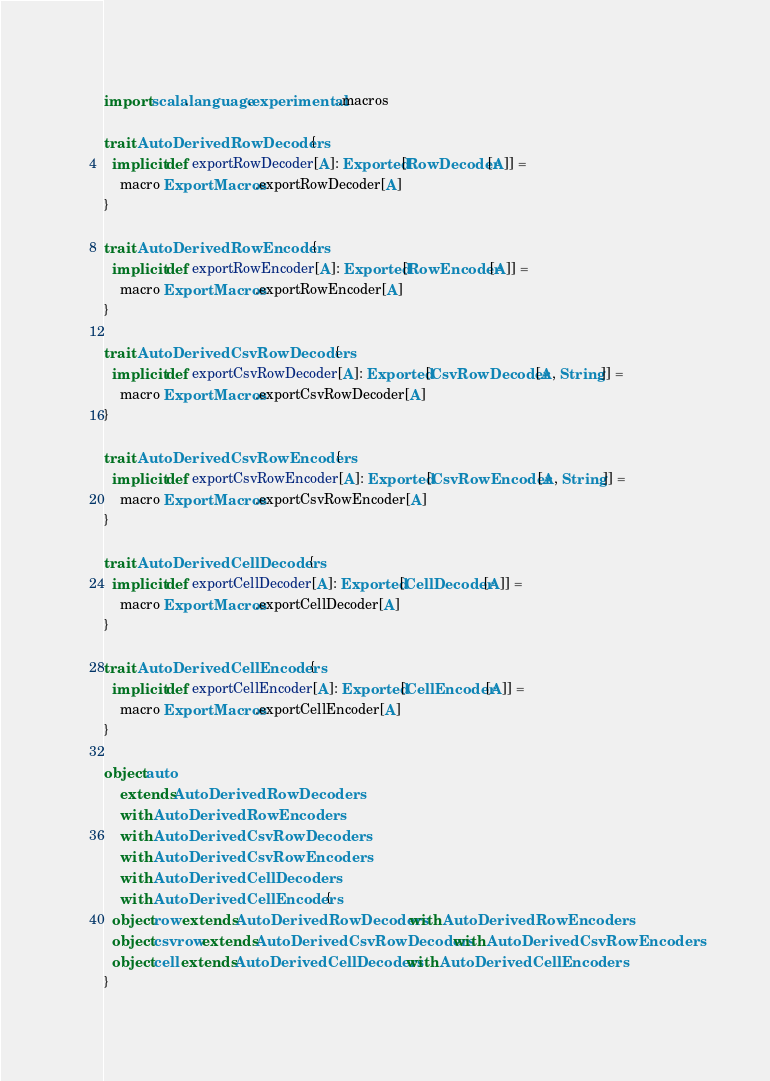<code> <loc_0><loc_0><loc_500><loc_500><_Scala_>
import scala.language.experimental.macros

trait AutoDerivedRowDecoders {
  implicit def exportRowDecoder[A]: Exported[RowDecoder[A]] =
    macro ExportMacros.exportRowDecoder[A]
}

trait AutoDerivedRowEncoders {
  implicit def exportRowEncoder[A]: Exported[RowEncoder[A]] =
    macro ExportMacros.exportRowEncoder[A]
}

trait AutoDerivedCsvRowDecoders {
  implicit def exportCsvRowDecoder[A]: Exported[CsvRowDecoder[A, String]] =
    macro ExportMacros.exportCsvRowDecoder[A]
}

trait AutoDerivedCsvRowEncoders {
  implicit def exportCsvRowEncoder[A]: Exported[CsvRowEncoder[A, String]] =
    macro ExportMacros.exportCsvRowEncoder[A]
}

trait AutoDerivedCellDecoders {
  implicit def exportCellDecoder[A]: Exported[CellDecoder[A]] =
    macro ExportMacros.exportCellDecoder[A]
}

trait AutoDerivedCellEncoders {
  implicit def exportCellEncoder[A]: Exported[CellEncoder[A]] =
    macro ExportMacros.exportCellEncoder[A]
}

object auto
    extends AutoDerivedRowDecoders
    with AutoDerivedRowEncoders
    with AutoDerivedCsvRowDecoders
    with AutoDerivedCsvRowEncoders
    with AutoDerivedCellDecoders
    with AutoDerivedCellEncoders {
  object row extends AutoDerivedRowDecoders with AutoDerivedRowEncoders
  object csvrow extends AutoDerivedCsvRowDecoders with AutoDerivedCsvRowEncoders
  object cell extends AutoDerivedCellDecoders with AutoDerivedCellEncoders
}
</code> 